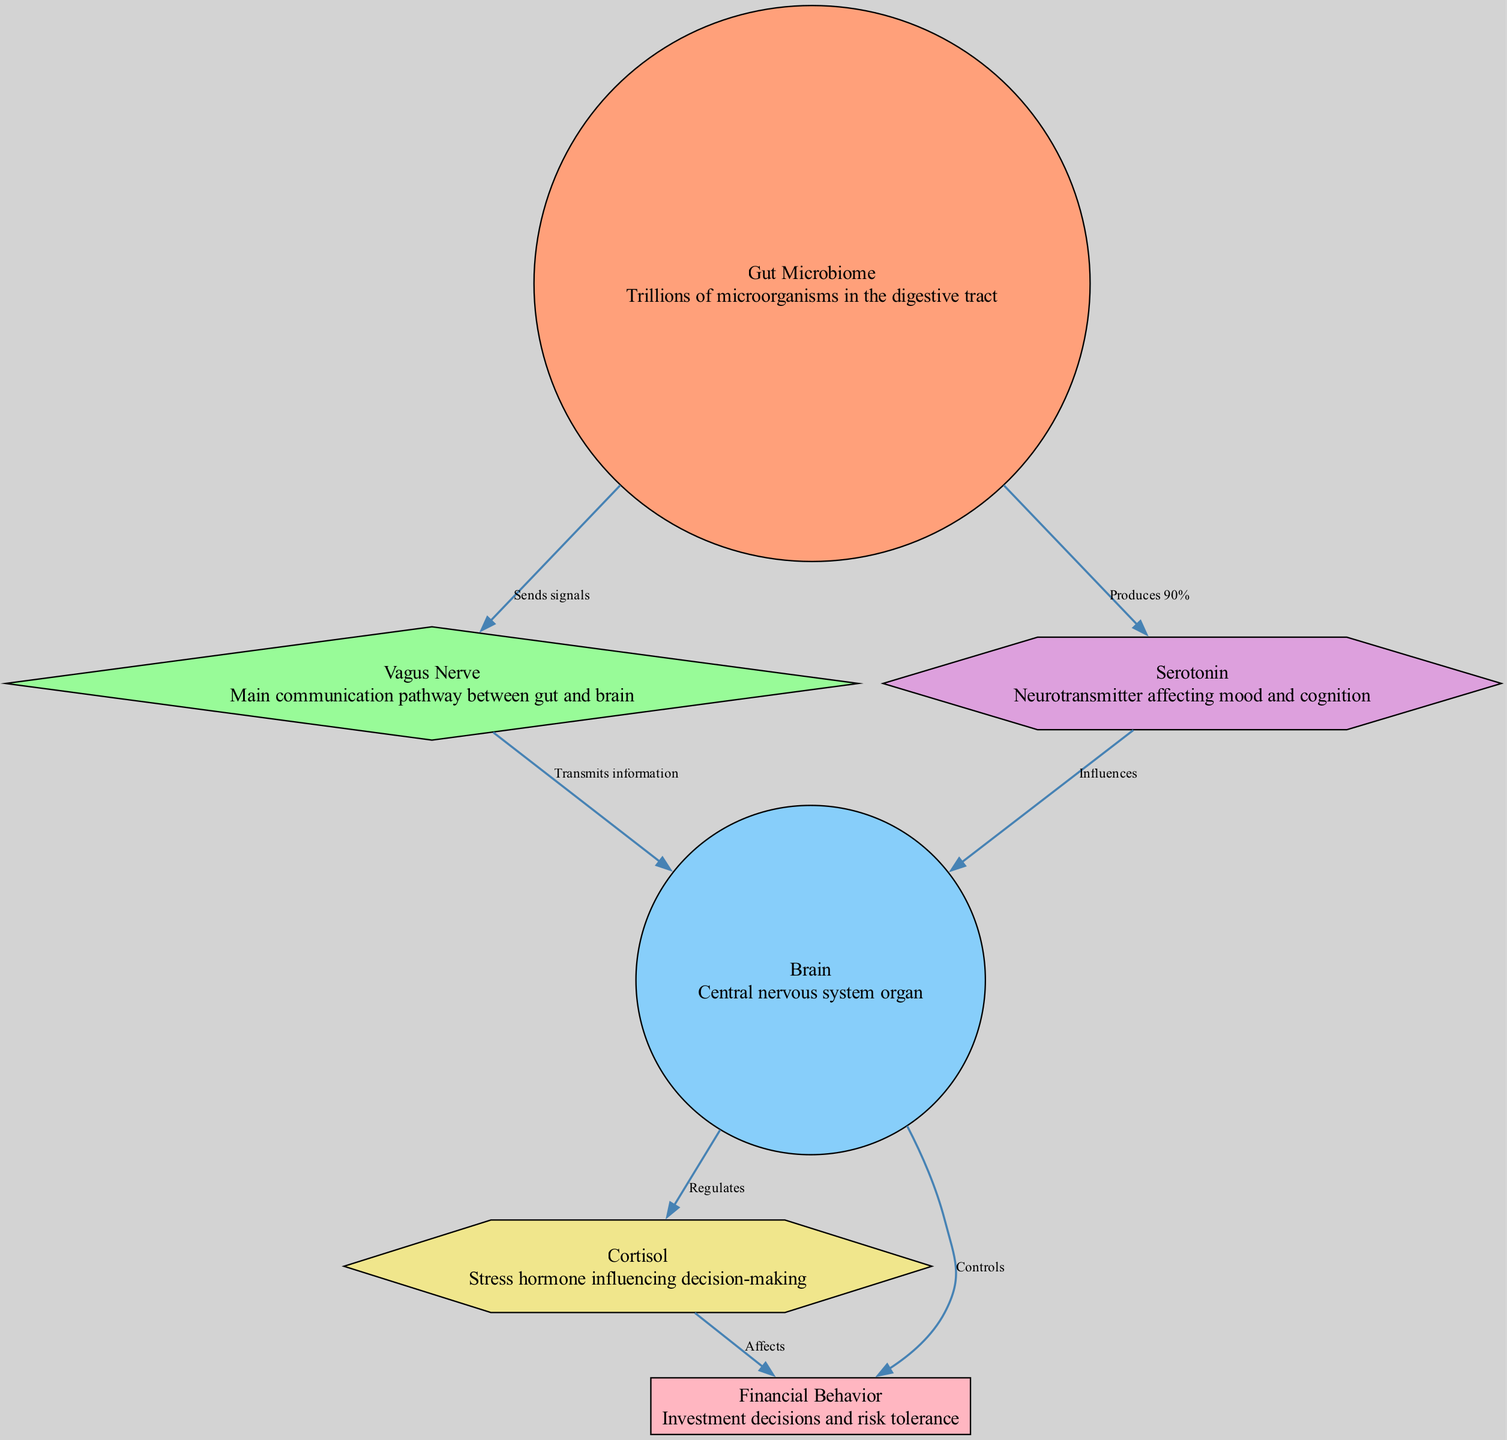What is the primary component of the gut microbiome? The diagram indicates that the "Gut Microbiome" contains "Trillions of microorganisms in the digestive tract," so the primary component is microorganisms.
Answer: microorganisms How many edges are present in the diagram? To find the number of edges, we can count each connection (or edge) between nodes shown in the diagram. There are a total of 7 edges connecting different nodes.
Answer: 7 What is the function of the vagus nerve? The diagram states that the vagus nerve "Transmits information" from the gut to the brain, indicating its role in communication between these areas.
Answer: Transmits information Which neurotransmitter is produced by the gut? According to the diagram, the gut produces "90%" of serotonin, which is the neurotransmitter in question linked to mood and cognition.
Answer: serotonin How does cortisol affect financial behavior? The diagram shows a direct connection where cortisol "Affects" financial behavior, indicating that increased stress hormone levels impact investment decisions and risk tolerance.
Answer: Affects What influences the regulation of cortisol? The diagram indicates that the brain "Regulates" cortisol levels, implying that the brain plays a crucial role in controlling the amount of this stress hormone in the body.
Answer: Regulates What is the relationship between serotonin and the brain? The diagram depicts that serotonin "Influences" the brain, meaning that serotonin has a significant impact on the brain's functions, particularly mood and cognition.
Answer: Influences Which element controls behavior according to the diagram? The brain is indicated to "Controls" behavior in the diagram, suggesting it has a primary regulatory role in shaping financial behavior and decision-making.
Answer: Controls What type of communication occurs between the gut and brain? The diagram specifies that communication occurs via "Sends signals" from the gut to the vagus nerve and "Transmits information" from the vagus nerve to the brain, reflecting the nature of this interaction.
Answer: Sends signals, Transmits information 